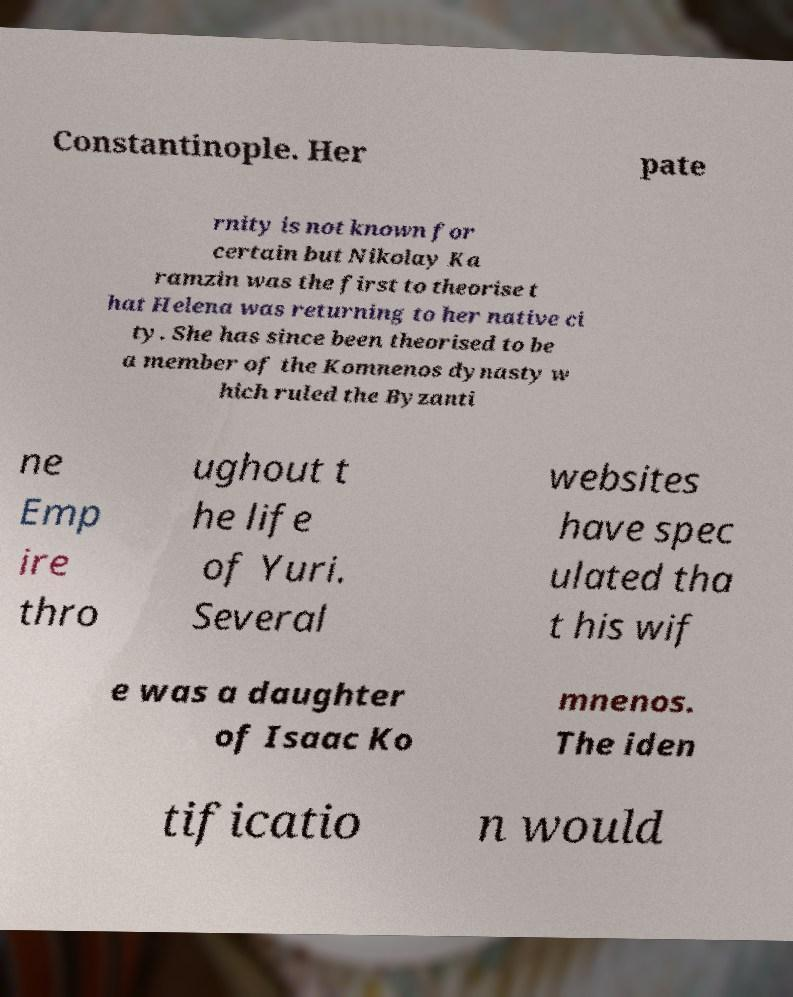I need the written content from this picture converted into text. Can you do that? Constantinople. Her pate rnity is not known for certain but Nikolay Ka ramzin was the first to theorise t hat Helena was returning to her native ci ty. She has since been theorised to be a member of the Komnenos dynasty w hich ruled the Byzanti ne Emp ire thro ughout t he life of Yuri. Several websites have spec ulated tha t his wif e was a daughter of Isaac Ko mnenos. The iden tificatio n would 